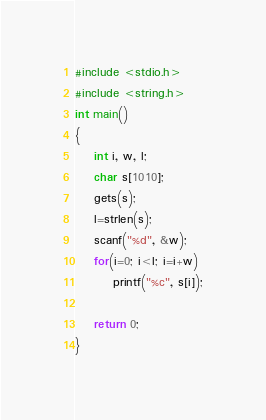<code> <loc_0><loc_0><loc_500><loc_500><_C++_>#include <stdio.h>
#include <string.h>
int main()
{
    int i, w, l;
    char s[1010];
    gets(s);
    l=strlen(s);
    scanf("%d", &w);
    for(i=0; i<l; i=i+w)
        printf("%c", s[i]);

    return 0;
}</code> 